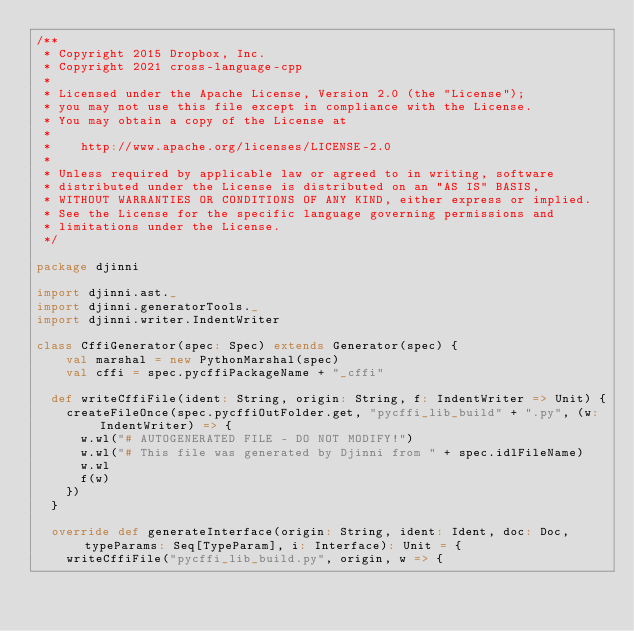Convert code to text. <code><loc_0><loc_0><loc_500><loc_500><_Scala_>/**
 * Copyright 2015 Dropbox, Inc.
 * Copyright 2021 cross-language-cpp
 *
 * Licensed under the Apache License, Version 2.0 (the "License");
 * you may not use this file except in compliance with the License.
 * You may obtain a copy of the License at
 *
 *    http://www.apache.org/licenses/LICENSE-2.0
 *
 * Unless required by applicable law or agreed to in writing, software
 * distributed under the License is distributed on an "AS IS" BASIS,
 * WITHOUT WARRANTIES OR CONDITIONS OF ANY KIND, either express or implied.
 * See the License for the specific language governing permissions and
 * limitations under the License.
 */

package djinni

import djinni.ast._
import djinni.generatorTools._
import djinni.writer.IndentWriter

class CffiGenerator(spec: Spec) extends Generator(spec) {
    val marshal = new PythonMarshal(spec)
    val cffi = spec.pycffiPackageName + "_cffi"

  def writeCffiFile(ident: String, origin: String, f: IndentWriter => Unit) {
    createFileOnce(spec.pycffiOutFolder.get, "pycffi_lib_build" + ".py", (w: IndentWriter) => {
      w.wl("# AUTOGENERATED FILE - DO NOT MODIFY!")
      w.wl("# This file was generated by Djinni from " + spec.idlFileName)
      w.wl
      f(w)
    })
  }

  override def generateInterface(origin: String, ident: Ident, doc: Doc, typeParams: Seq[TypeParam], i: Interface): Unit = {
    writeCffiFile("pycffi_lib_build.py", origin, w => {</code> 